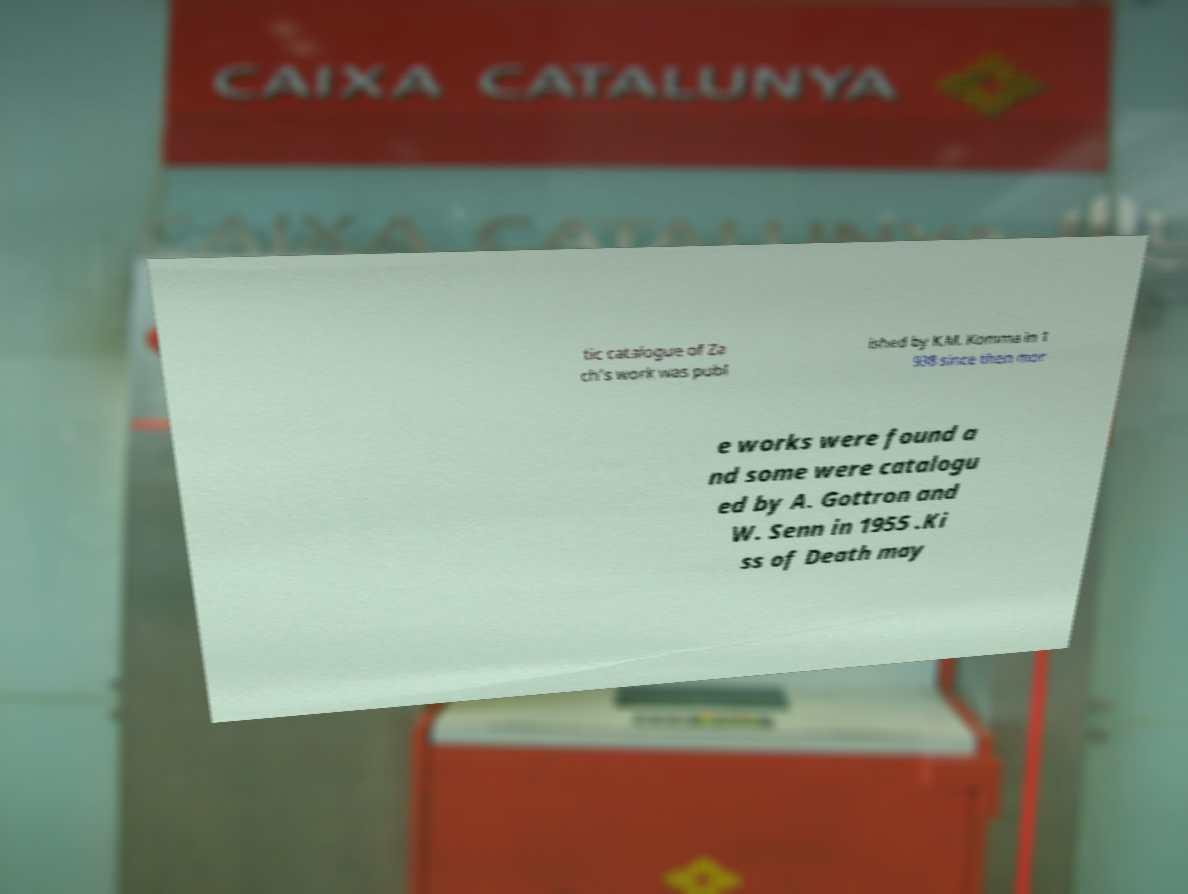Could you extract and type out the text from this image? tic catalogue of Za ch's work was publ ished by K.M. Komma in 1 938 since then mor e works were found a nd some were catalogu ed by A. Gottron and W. Senn in 1955 .Ki ss of Death may 